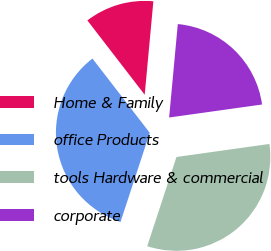Convert chart to OTSL. <chart><loc_0><loc_0><loc_500><loc_500><pie_chart><fcel>Home & Family<fcel>office Products<fcel>tools Hardware & commercial<fcel>corporate<nl><fcel>11.93%<fcel>34.49%<fcel>32.26%<fcel>21.31%<nl></chart> 